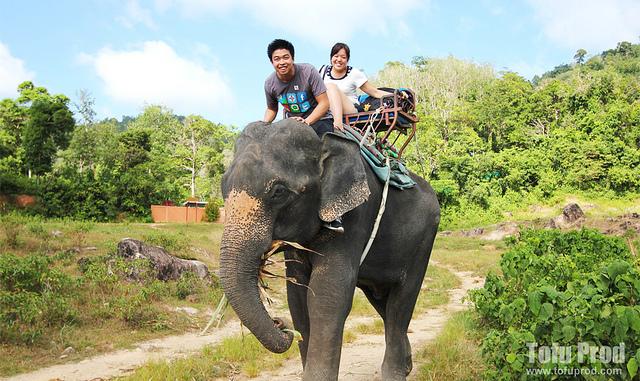What are the elephants wearing?
Answer briefly. Saddle. Are the people high up off the ground?
Give a very brief answer. Yes. Do you think these people are on vacation?
Concise answer only. Yes. What are the people riding?
Quick response, please. Elephant. 